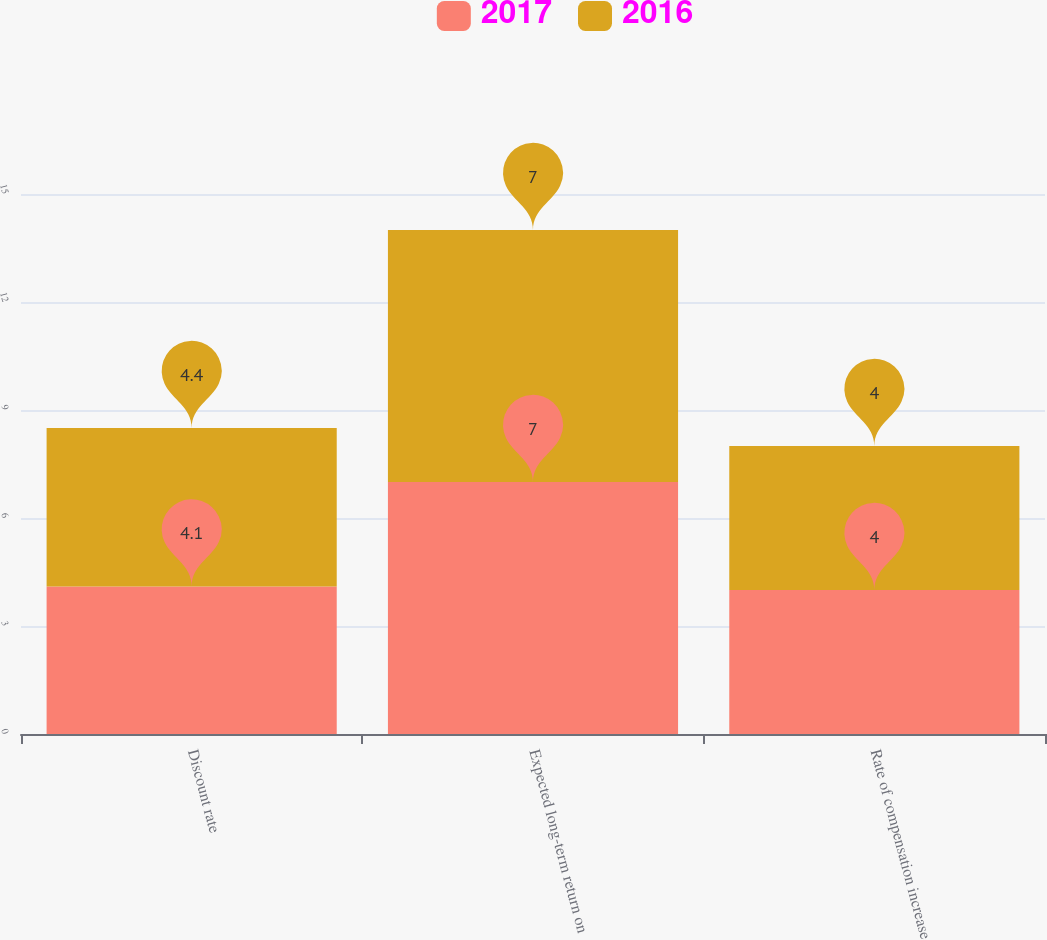<chart> <loc_0><loc_0><loc_500><loc_500><stacked_bar_chart><ecel><fcel>Discount rate<fcel>Expected long-term return on<fcel>Rate of compensation increase<nl><fcel>2017<fcel>4.1<fcel>7<fcel>4<nl><fcel>2016<fcel>4.4<fcel>7<fcel>4<nl></chart> 